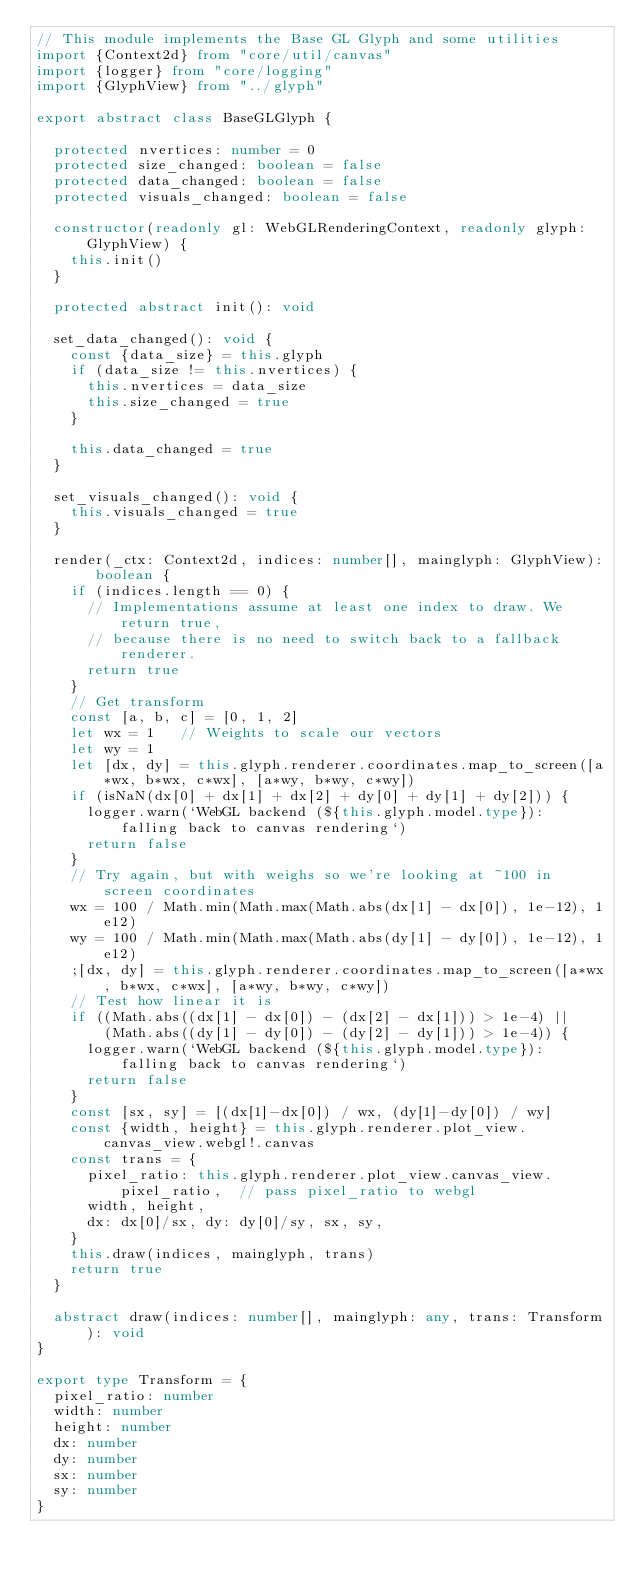Convert code to text. <code><loc_0><loc_0><loc_500><loc_500><_TypeScript_>// This module implements the Base GL Glyph and some utilities
import {Context2d} from "core/util/canvas"
import {logger} from "core/logging"
import {GlyphView} from "../glyph"

export abstract class BaseGLGlyph {

  protected nvertices: number = 0
  protected size_changed: boolean = false
  protected data_changed: boolean = false
  protected visuals_changed: boolean = false

  constructor(readonly gl: WebGLRenderingContext, readonly glyph: GlyphView) {
    this.init()
  }

  protected abstract init(): void

  set_data_changed(): void {
    const {data_size} = this.glyph
    if (data_size != this.nvertices) {
      this.nvertices = data_size
      this.size_changed = true
    }

    this.data_changed = true
  }

  set_visuals_changed(): void {
    this.visuals_changed = true
  }

  render(_ctx: Context2d, indices: number[], mainglyph: GlyphView): boolean {
    if (indices.length == 0) {
      // Implementations assume at least one index to draw. We return true,
      // because there is no need to switch back to a fallback renderer.
      return true
    }
    // Get transform
    const [a, b, c] = [0, 1, 2]
    let wx = 1   // Weights to scale our vectors
    let wy = 1
    let [dx, dy] = this.glyph.renderer.coordinates.map_to_screen([a*wx, b*wx, c*wx], [a*wy, b*wy, c*wy])
    if (isNaN(dx[0] + dx[1] + dx[2] + dy[0] + dy[1] + dy[2])) {
      logger.warn(`WebGL backend (${this.glyph.model.type}): falling back to canvas rendering`)
      return false
    }
    // Try again, but with weighs so we're looking at ~100 in screen coordinates
    wx = 100 / Math.min(Math.max(Math.abs(dx[1] - dx[0]), 1e-12), 1e12)
    wy = 100 / Math.min(Math.max(Math.abs(dy[1] - dy[0]), 1e-12), 1e12)
    ;[dx, dy] = this.glyph.renderer.coordinates.map_to_screen([a*wx, b*wx, c*wx], [a*wy, b*wy, c*wy])
    // Test how linear it is
    if ((Math.abs((dx[1] - dx[0]) - (dx[2] - dx[1])) > 1e-4) ||
        (Math.abs((dy[1] - dy[0]) - (dy[2] - dy[1])) > 1e-4)) {
      logger.warn(`WebGL backend (${this.glyph.model.type}): falling back to canvas rendering`)
      return false
    }
    const [sx, sy] = [(dx[1]-dx[0]) / wx, (dy[1]-dy[0]) / wy]
    const {width, height} = this.glyph.renderer.plot_view.canvas_view.webgl!.canvas
    const trans = {
      pixel_ratio: this.glyph.renderer.plot_view.canvas_view.pixel_ratio,  // pass pixel_ratio to webgl
      width, height,
      dx: dx[0]/sx, dy: dy[0]/sy, sx, sy,
    }
    this.draw(indices, mainglyph, trans)
    return true
  }

  abstract draw(indices: number[], mainglyph: any, trans: Transform): void
}

export type Transform = {
  pixel_ratio: number
  width: number
  height: number
  dx: number
  dy: number
  sx: number
  sy: number
}
</code> 